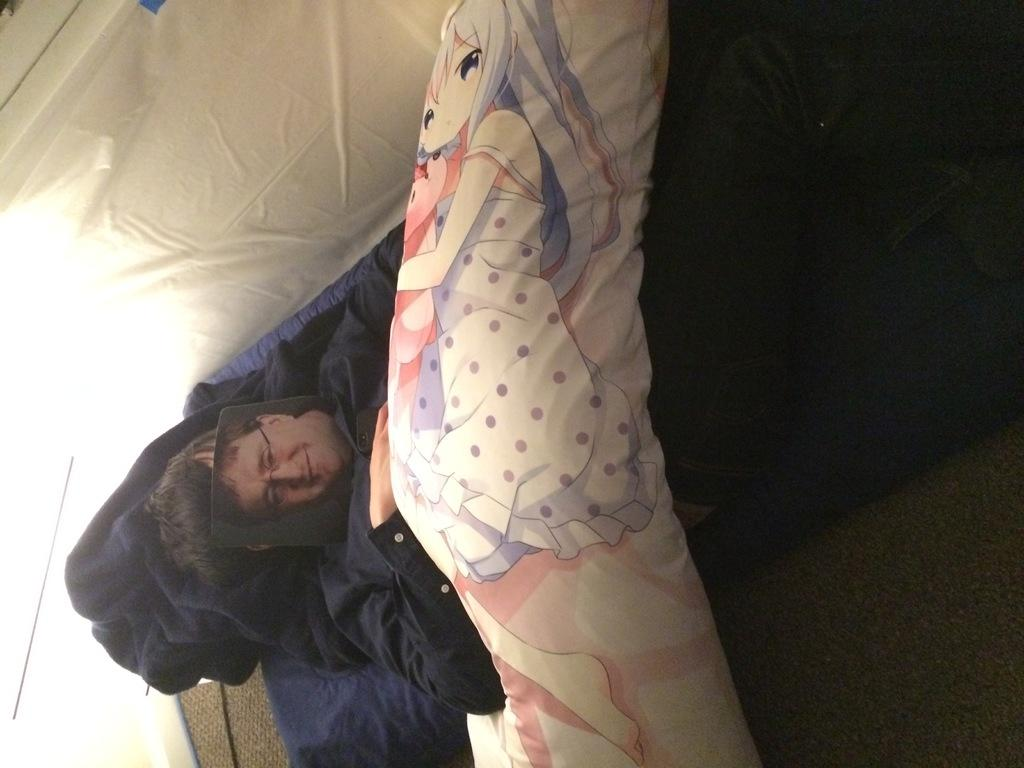What is the main setting of the image? The image is of a room. What is the person in the room doing? There is a person lying on the bed in the room. What type of decoration is on the blanket? There is a picture of a cartoon on the blanket. What color is the cloth at the back of the room? There is a white color cloth at the back of the room. How many snails can be seen crawling on the person's sweater in the image? There are no snails or sweaters present in the image; it features a person lying on a bed in a room with a cartoon picture on the blanket and a white cloth at the back. 